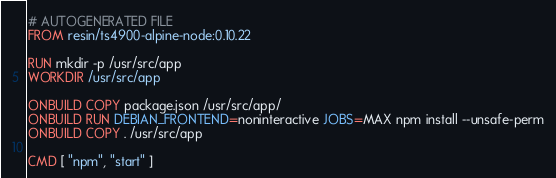Convert code to text. <code><loc_0><loc_0><loc_500><loc_500><_Dockerfile_># AUTOGENERATED FILE
FROM resin/ts4900-alpine-node:0.10.22

RUN mkdir -p /usr/src/app
WORKDIR /usr/src/app

ONBUILD COPY package.json /usr/src/app/
ONBUILD RUN DEBIAN_FRONTEND=noninteractive JOBS=MAX npm install --unsafe-perm
ONBUILD COPY . /usr/src/app

CMD [ "npm", "start" ]
</code> 